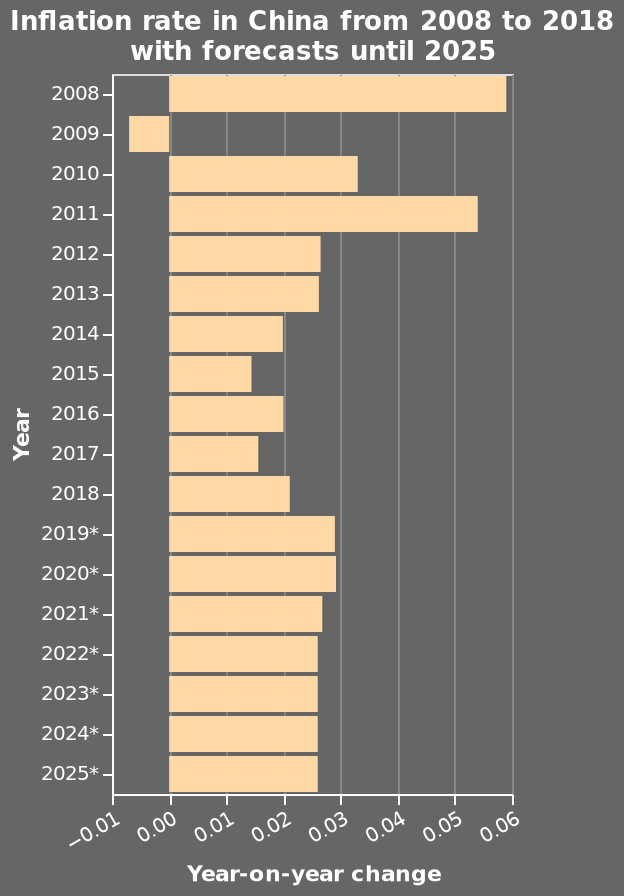<image>
How would you describe the overall trend of inflation during the given period? The overall trend of inflation during the given period has been steady, with a peak in 2008 and a year of deflation following it, and then remaining relatively low between 2014 and 2018. What does the x-axis represent in the bar chart? The x-axis represents the Year-on-year change. 